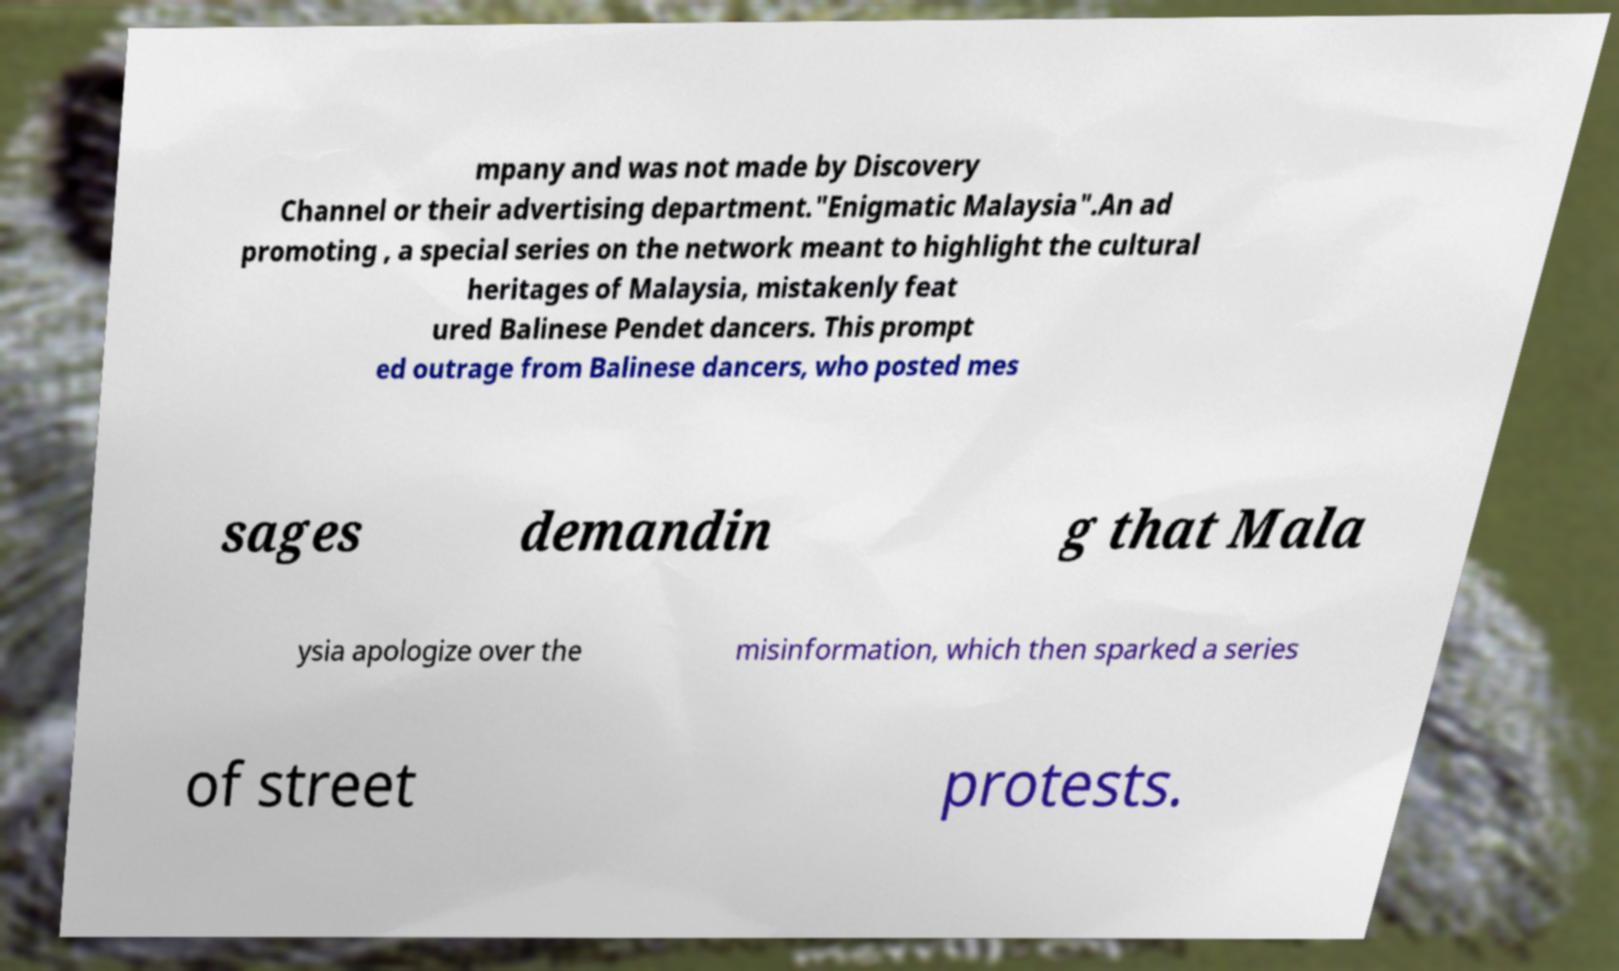Can you read and provide the text displayed in the image?This photo seems to have some interesting text. Can you extract and type it out for me? mpany and was not made by Discovery Channel or their advertising department."Enigmatic Malaysia".An ad promoting , a special series on the network meant to highlight the cultural heritages of Malaysia, mistakenly feat ured Balinese Pendet dancers. This prompt ed outrage from Balinese dancers, who posted mes sages demandin g that Mala ysia apologize over the misinformation, which then sparked a series of street protests. 